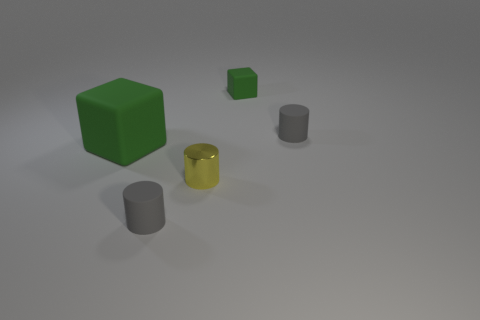What number of green things are big matte objects or tiny rubber cubes?
Your response must be concise. 2. What color is the tiny rubber thing that is in front of the small green object and behind the large green matte cube?
Provide a succinct answer. Gray. Is the material of the gray object that is left of the yellow metallic thing the same as the yellow cylinder to the right of the big green cube?
Your answer should be compact. No. Are there more tiny gray cylinders behind the small yellow metallic thing than small green cubes that are in front of the big green thing?
Offer a very short reply. Yes. What number of objects are either red cylinders or gray things that are in front of the small shiny cylinder?
Ensure brevity in your answer.  1. Does the big cube have the same color as the tiny cube?
Provide a short and direct response. Yes. There is a small metallic thing; what number of tiny metallic cylinders are right of it?
Ensure brevity in your answer.  0. There is a small block that is the same material as the big green object; what color is it?
Your response must be concise. Green. What number of shiny things are tiny purple cylinders or green objects?
Make the answer very short. 0. Do the tiny green object and the big cube have the same material?
Provide a short and direct response. Yes. 